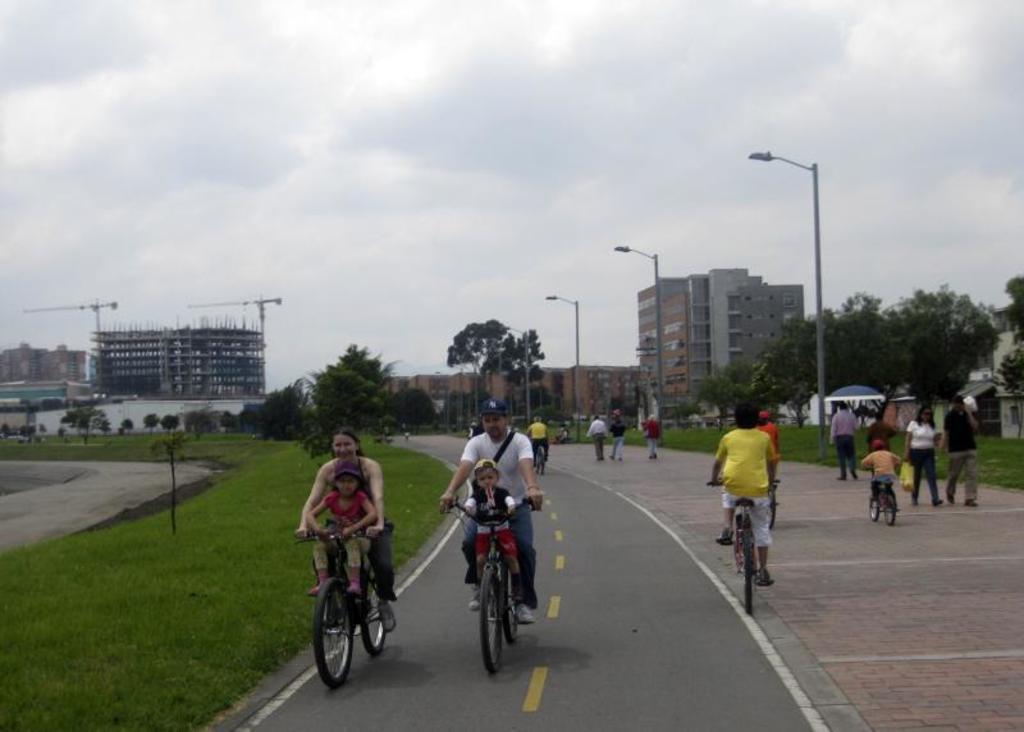Please provide a concise description of this image. In this picture there is a man who is wearing, white t-shirt, jeans, cap, bag and shoe. He is riding bicycle. In front of him we can see a boy who is sitting on the bicycle. Beside him we can see woman who is also riding a bicycle on the road. On the right we can see many peoples who are walking on the street. Here we can see of street lights near to the parking area. In the background we can see buildings, trees, plants and cranes. On the top we can see sky and clouds. On the bottom left corner we can see grass. 